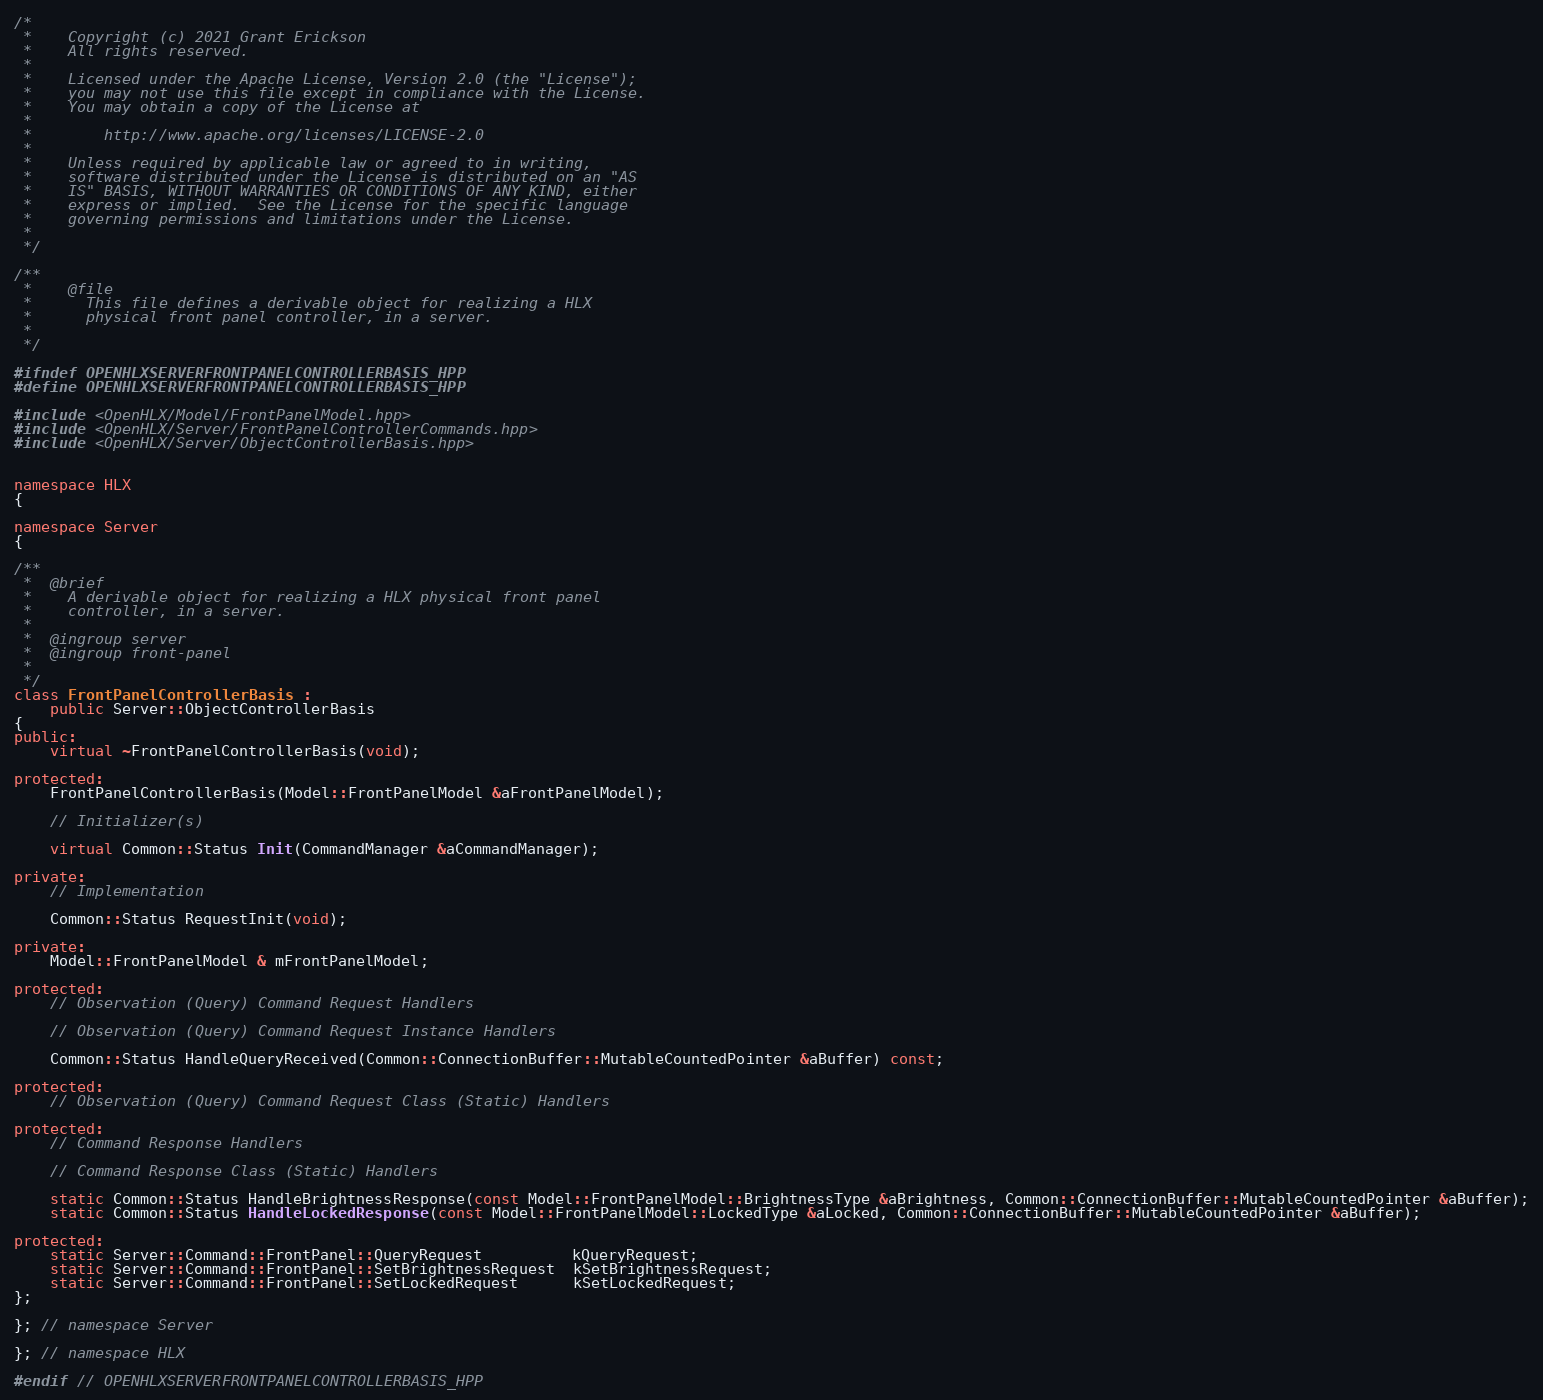<code> <loc_0><loc_0><loc_500><loc_500><_C++_>/*
 *    Copyright (c) 2021 Grant Erickson
 *    All rights reserved.
 *
 *    Licensed under the Apache License, Version 2.0 (the "License");
 *    you may not use this file except in compliance with the License.
 *    You may obtain a copy of the License at
 *
 *        http://www.apache.org/licenses/LICENSE-2.0
 *
 *    Unless required by applicable law or agreed to in writing,
 *    software distributed under the License is distributed on an "AS
 *    IS" BASIS, WITHOUT WARRANTIES OR CONDITIONS OF ANY KIND, either
 *    express or implied.  See the License for the specific language
 *    governing permissions and limitations under the License.
 *
 */

/**
 *    @file
 *      This file defines a derivable object for realizing a HLX
 *      physical front panel controller, in a server.
 *
 */

#ifndef OPENHLXSERVERFRONTPANELCONTROLLERBASIS_HPP
#define OPENHLXSERVERFRONTPANELCONTROLLERBASIS_HPP

#include <OpenHLX/Model/FrontPanelModel.hpp>
#include <OpenHLX/Server/FrontPanelControllerCommands.hpp>
#include <OpenHLX/Server/ObjectControllerBasis.hpp>


namespace HLX
{

namespace Server
{

/**
 *  @brief
 *    A derivable object for realizing a HLX physical front panel
 *    controller, in a server.
 *
 *  @ingroup server
 *  @ingroup front-panel
 *
 */
class FrontPanelControllerBasis :
    public Server::ObjectControllerBasis
{
public:
    virtual ~FrontPanelControllerBasis(void);

protected:
    FrontPanelControllerBasis(Model::FrontPanelModel &aFrontPanelModel);

    // Initializer(s)

    virtual Common::Status Init(CommandManager &aCommandManager);

private:
    // Implementation

    Common::Status RequestInit(void);

private:
    Model::FrontPanelModel & mFrontPanelModel;

protected:
    // Observation (Query) Command Request Handlers

    // Observation (Query) Command Request Instance Handlers

    Common::Status HandleQueryReceived(Common::ConnectionBuffer::MutableCountedPointer &aBuffer) const;

protected:
    // Observation (Query) Command Request Class (Static) Handlers

protected:
    // Command Response Handlers

    // Command Response Class (Static) Handlers

    static Common::Status HandleBrightnessResponse(const Model::FrontPanelModel::BrightnessType &aBrightness, Common::ConnectionBuffer::MutableCountedPointer &aBuffer);
    static Common::Status HandleLockedResponse(const Model::FrontPanelModel::LockedType &aLocked, Common::ConnectionBuffer::MutableCountedPointer &aBuffer);

protected:
    static Server::Command::FrontPanel::QueryRequest          kQueryRequest;
    static Server::Command::FrontPanel::SetBrightnessRequest  kSetBrightnessRequest;
    static Server::Command::FrontPanel::SetLockedRequest      kSetLockedRequest;
};

}; // namespace Server

}; // namespace HLX

#endif // OPENHLXSERVERFRONTPANELCONTROLLERBASIS_HPP
</code> 